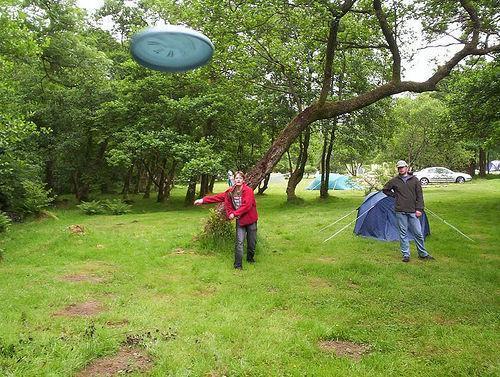How many people are there?
Give a very brief answer. 2. How many hooves does the horse have on the ground?
Give a very brief answer. 0. 